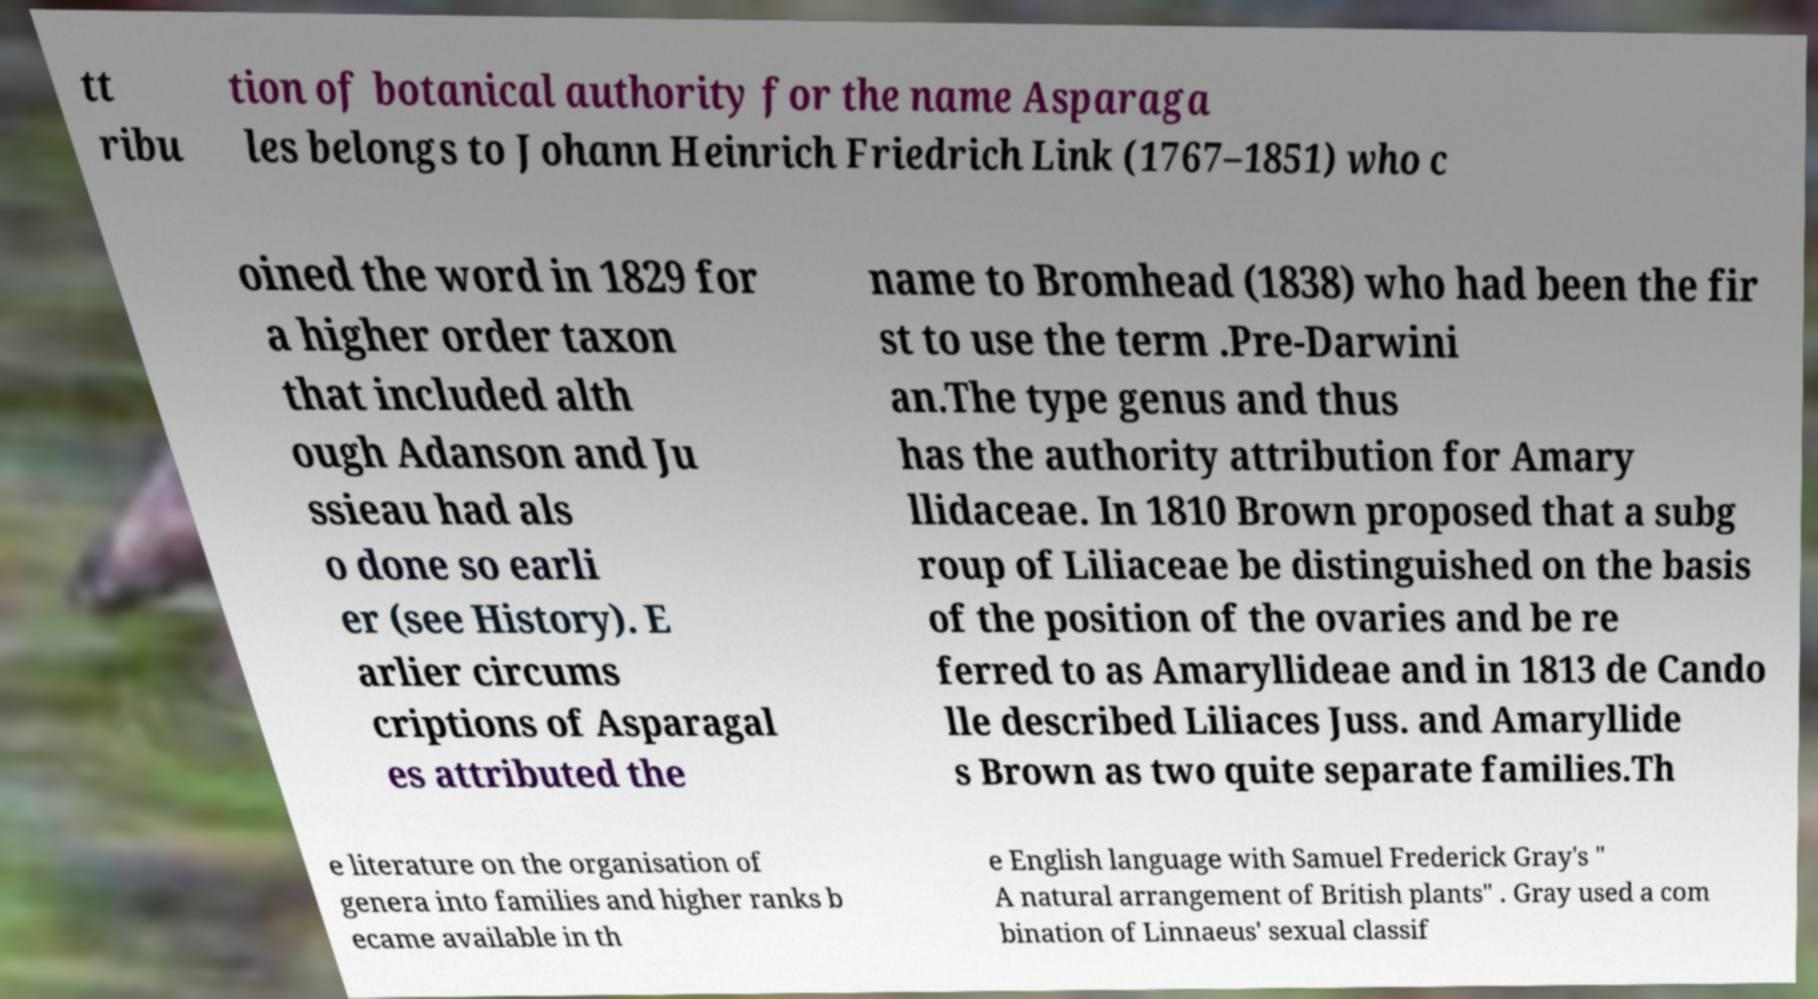What messages or text are displayed in this image? I need them in a readable, typed format. tt ribu tion of botanical authority for the name Asparaga les belongs to Johann Heinrich Friedrich Link (1767–1851) who c oined the word in 1829 for a higher order taxon that included alth ough Adanson and Ju ssieau had als o done so earli er (see History). E arlier circums criptions of Asparagal es attributed the name to Bromhead (1838) who had been the fir st to use the term .Pre-Darwini an.The type genus and thus has the authority attribution for Amary llidaceae. In 1810 Brown proposed that a subg roup of Liliaceae be distinguished on the basis of the position of the ovaries and be re ferred to as Amaryllideae and in 1813 de Cando lle described Liliaces Juss. and Amaryllide s Brown as two quite separate families.Th e literature on the organisation of genera into families and higher ranks b ecame available in th e English language with Samuel Frederick Gray's " A natural arrangement of British plants" . Gray used a com bination of Linnaeus' sexual classif 